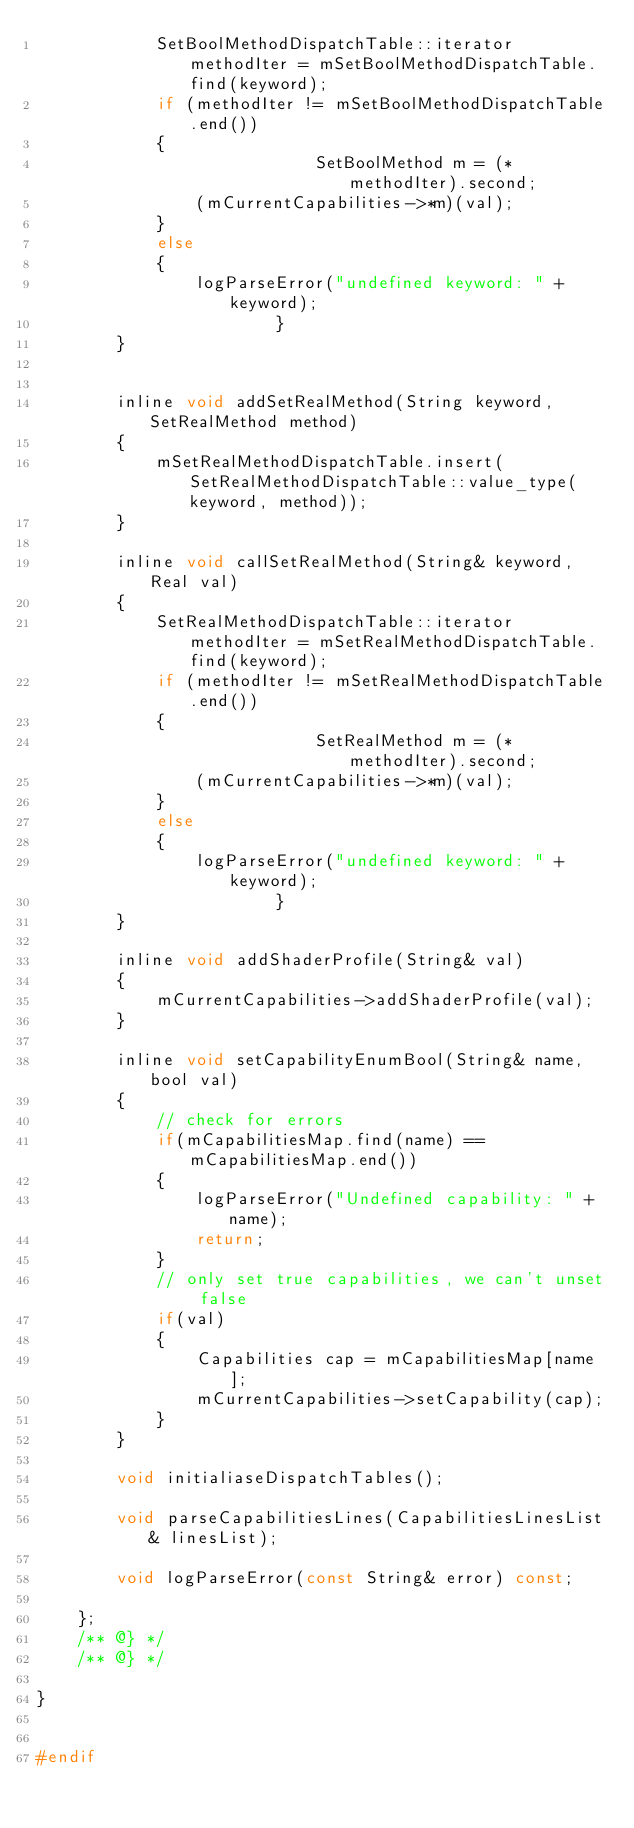Convert code to text. <code><loc_0><loc_0><loc_500><loc_500><_C_>            SetBoolMethodDispatchTable::iterator methodIter = mSetBoolMethodDispatchTable.find(keyword);
            if (methodIter != mSetBoolMethodDispatchTable.end())
            {
                            SetBoolMethod m = (*methodIter).second;
                (mCurrentCapabilities->*m)(val);
            }
            else
            {
                logParseError("undefined keyword: " + keyword);
                        }
        }


        inline void addSetRealMethod(String keyword, SetRealMethod method)
        {
            mSetRealMethodDispatchTable.insert(SetRealMethodDispatchTable::value_type(keyword, method));
        }

        inline void callSetRealMethod(String& keyword, Real val)
        {
            SetRealMethodDispatchTable::iterator methodIter = mSetRealMethodDispatchTable.find(keyword);
            if (methodIter != mSetRealMethodDispatchTable.end())
            {
                            SetRealMethod m = (*methodIter).second;
                (mCurrentCapabilities->*m)(val);
            }
            else
            {
                logParseError("undefined keyword: " + keyword);
                        }
        }

        inline void addShaderProfile(String& val)
        {
            mCurrentCapabilities->addShaderProfile(val);
        }

        inline void setCapabilityEnumBool(String& name, bool val)
        {
            // check for errors
            if(mCapabilitiesMap.find(name) == mCapabilitiesMap.end())
            {
                logParseError("Undefined capability: " + name);
                return;
            }
            // only set true capabilities, we can't unset false
            if(val)
            {
                Capabilities cap = mCapabilitiesMap[name];
                mCurrentCapabilities->setCapability(cap);
            }
        }

        void initialiaseDispatchTables();

        void parseCapabilitiesLines(CapabilitiesLinesList& linesList);

        void logParseError(const String& error) const;

    };
    /** @} */
    /** @} */

}


#endif
</code> 